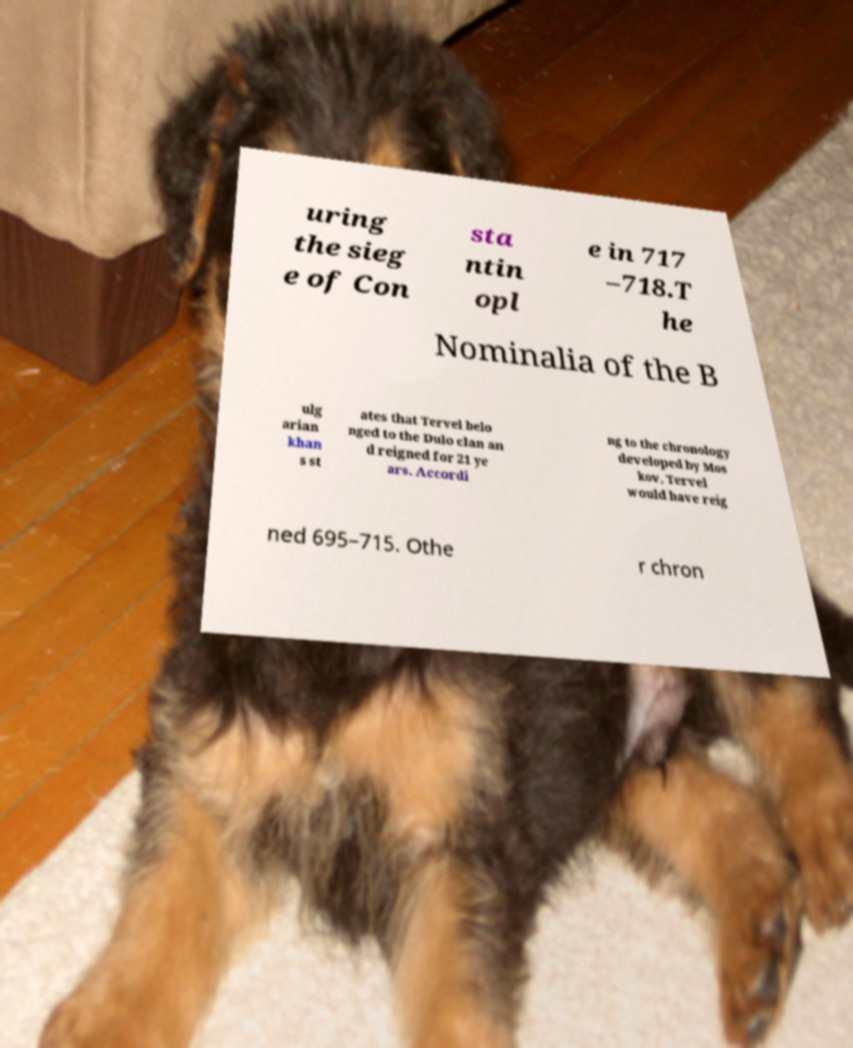Could you assist in decoding the text presented in this image and type it out clearly? uring the sieg e of Con sta ntin opl e in 717 –718.T he Nominalia of the B ulg arian khan s st ates that Tervel belo nged to the Dulo clan an d reigned for 21 ye ars. Accordi ng to the chronology developed by Mos kov, Tervel would have reig ned 695–715. Othe r chron 